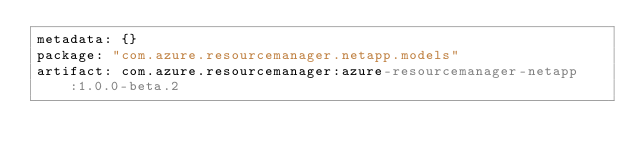<code> <loc_0><loc_0><loc_500><loc_500><_YAML_>metadata: {}
package: "com.azure.resourcemanager.netapp.models"
artifact: com.azure.resourcemanager:azure-resourcemanager-netapp:1.0.0-beta.2
</code> 